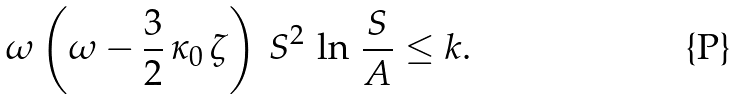Convert formula to latex. <formula><loc_0><loc_0><loc_500><loc_500>\omega \left ( \omega - \frac { 3 } { 2 } \, \kappa _ { 0 } \, \zeta \right ) \, S ^ { 2 } \, \ln \, \frac { S } { A } \leq k .</formula> 